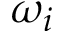<formula> <loc_0><loc_0><loc_500><loc_500>\omega _ { i }</formula> 